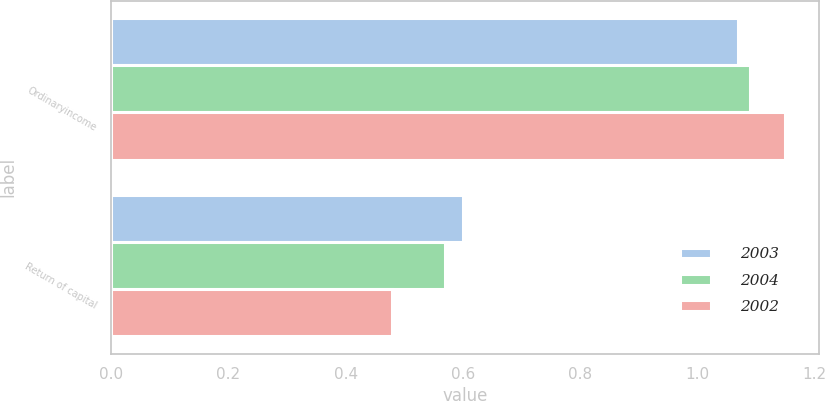<chart> <loc_0><loc_0><loc_500><loc_500><stacked_bar_chart><ecel><fcel>Ordinaryincome<fcel>Return of capital<nl><fcel>2003<fcel>1.07<fcel>0.6<nl><fcel>2004<fcel>1.09<fcel>0.57<nl><fcel>2002<fcel>1.15<fcel>0.48<nl></chart> 